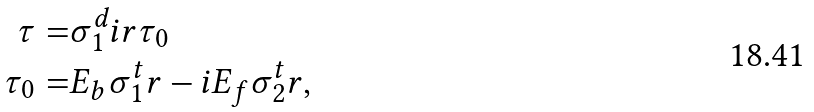<formula> <loc_0><loc_0><loc_500><loc_500>\tau = & \sigma _ { 1 } ^ { d } i r \tau _ { 0 } \\ \tau _ { 0 } = & E _ { b } \sigma _ { 1 } ^ { t } r - i E _ { f } \sigma _ { 2 } ^ { t } r ,</formula> 